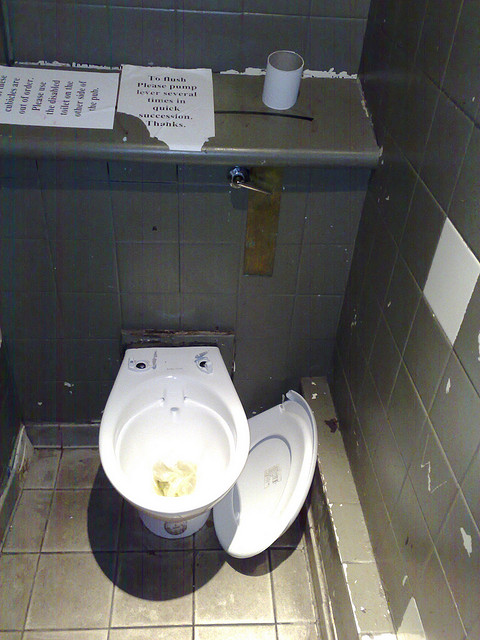Identify and read out the text in this image. QUICK succession 